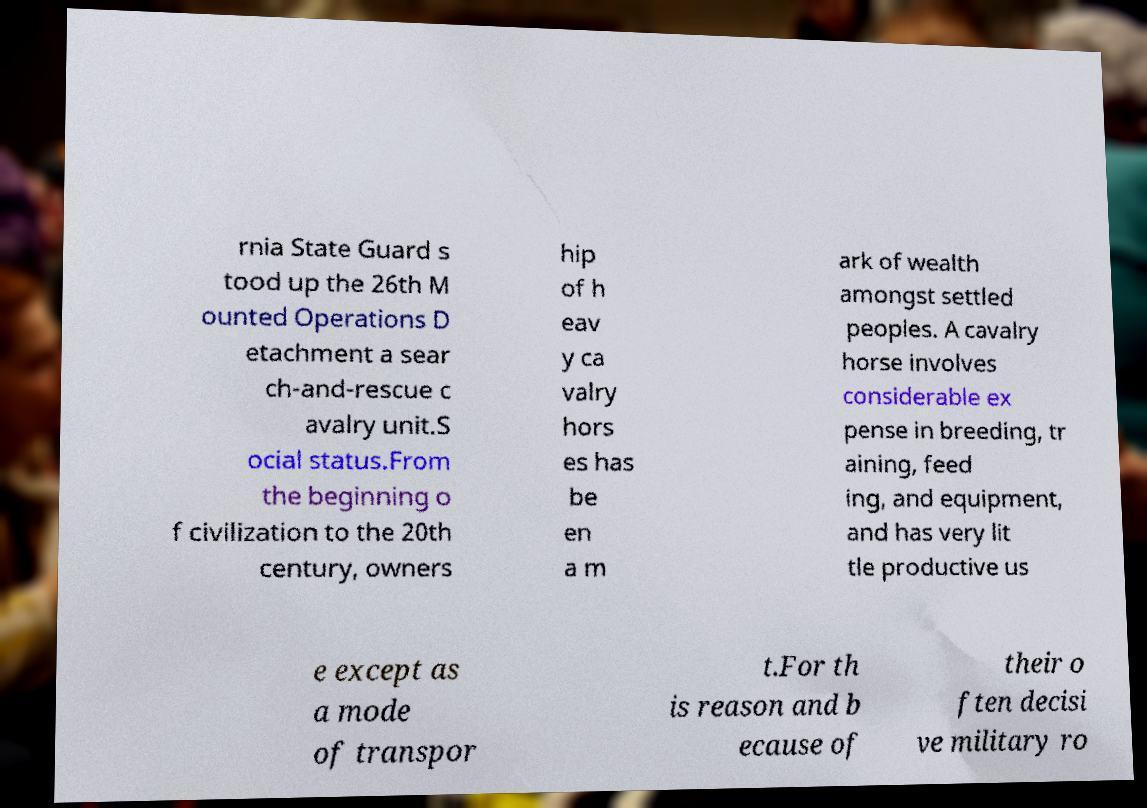Can you read and provide the text displayed in the image?This photo seems to have some interesting text. Can you extract and type it out for me? rnia State Guard s tood up the 26th M ounted Operations D etachment a sear ch-and-rescue c avalry unit.S ocial status.From the beginning o f civilization to the 20th century, owners hip of h eav y ca valry hors es has be en a m ark of wealth amongst settled peoples. A cavalry horse involves considerable ex pense in breeding, tr aining, feed ing, and equipment, and has very lit tle productive us e except as a mode of transpor t.For th is reason and b ecause of their o ften decisi ve military ro 